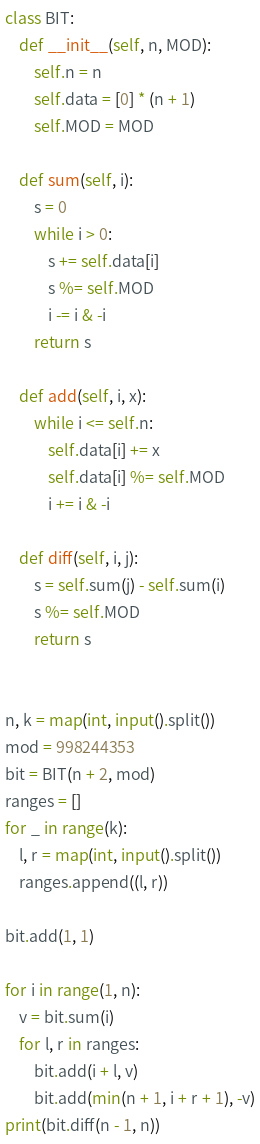<code> <loc_0><loc_0><loc_500><loc_500><_Python_>class BIT:
    def __init__(self, n, MOD):
        self.n = n
        self.data = [0] * (n + 1)
        self.MOD = MOD

    def sum(self, i):
        s = 0
        while i > 0:
            s += self.data[i]
            s %= self.MOD
            i -= i & -i
        return s

    def add(self, i, x):
        while i <= self.n:
            self.data[i] += x
            self.data[i] %= self.MOD
            i += i & -i

    def diff(self, i, j):
        s = self.sum(j) - self.sum(i)
        s %= self.MOD
        return s


n, k = map(int, input().split())
mod = 998244353
bit = BIT(n + 2, mod)
ranges = []
for _ in range(k):
    l, r = map(int, input().split())
    ranges.append((l, r))

bit.add(1, 1)

for i in range(1, n):
    v = bit.sum(i)
    for l, r in ranges:
        bit.add(i + l, v)
        bit.add(min(n + 1, i + r + 1), -v)
print(bit.diff(n - 1, n))
</code> 